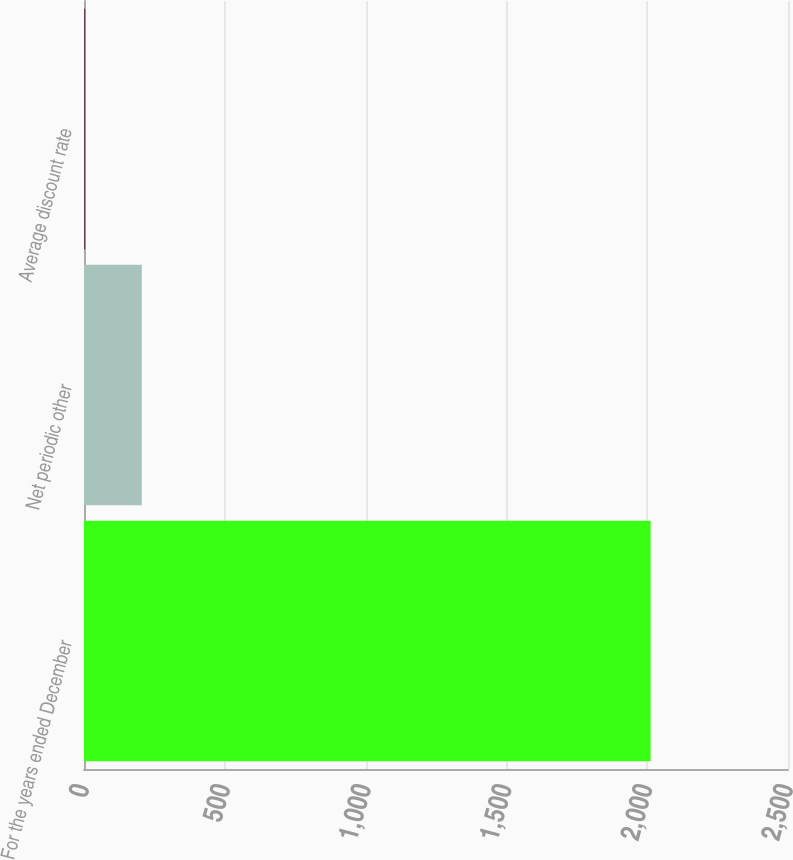<chart> <loc_0><loc_0><loc_500><loc_500><bar_chart><fcel>For the years ended December<fcel>Net periodic other<fcel>Average discount rate<nl><fcel>2012<fcel>205.25<fcel>4.5<nl></chart> 